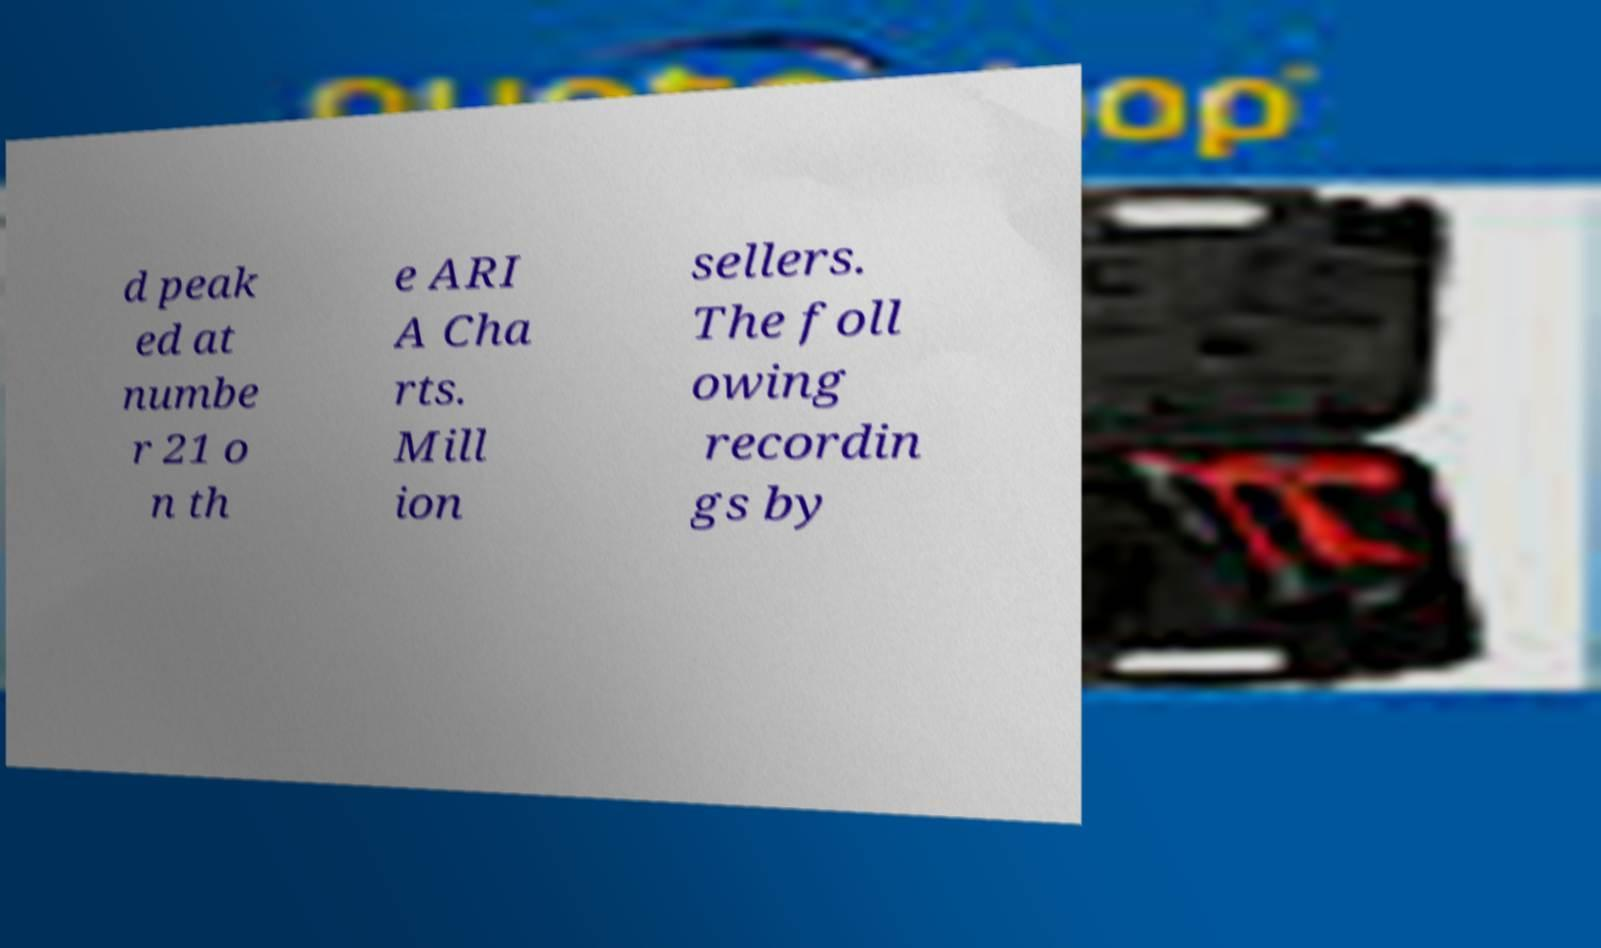I need the written content from this picture converted into text. Can you do that? d peak ed at numbe r 21 o n th e ARI A Cha rts. Mill ion sellers. The foll owing recordin gs by 